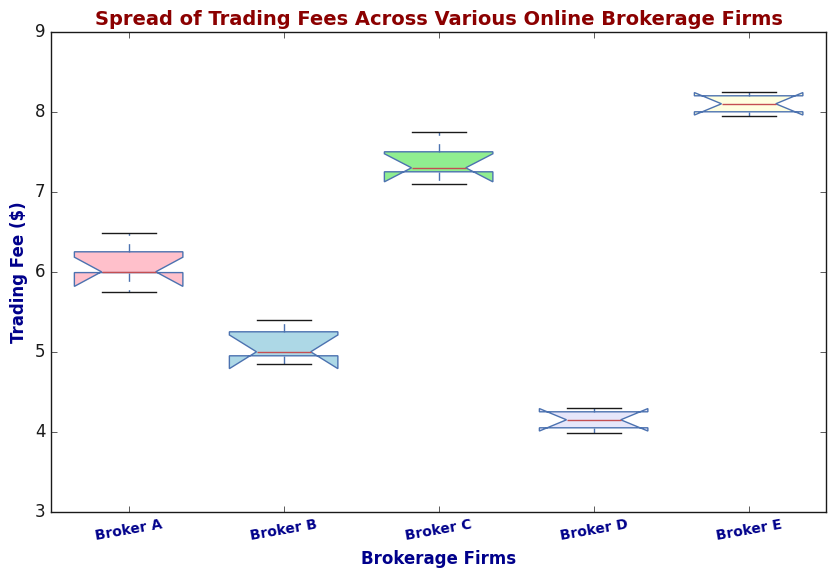What is the median trading fee for Broker D? The box plot shows the median (middle value) as a horizontal line inside the box for Broker D. The line is at the value of approximately 4.15.
Answer: Approximately 4.15 Which brokerage firm has the highest variability in trading fees? Variability is indicated by the spread between the whiskers of the box plot. Broker C has the widest distance between the top and bottom whiskers, indicating the highest variability.
Answer: Broker C What is the interquartile range (IQR) for Broker E? The IQR is the difference between the third quartile (Q3) and the first quartile (Q1). For Broker E, the third quartile appears to be around 8.2 and the first quartile around 8.0. Therefore, IQR = 8.2 - 8.0 = 0.2.
Answer: 0.2 Which brokerage firm has the lowest median trading fee? The median trading fee is shown by the line inside the box for each firm. Broker D has the lowest median trading fee at approximately 4.15.
Answer: Broker D Compare the median trading fees of Broker A and Broker B. Which one is higher? The median trading fee is represented by the horizontal line inside the box. Broker A has a median fee around 6.00, while Broker B has a median fee around 5.00. Thus, Broker A's median fee is higher.
Answer: Broker A Are there any outliers in the trading fees for Broker B? Outliers are typically shown as individual points outside the whiskers. For Broker B, there are no points outside the whiskers, indicating no outliers.
Answer: No What is the range of trading fees for Broker C? The range is the difference between the maximum and minimum values shown by the whiskers. For Broker C, the maximum is around 7.75 and the minimum is around 7.10, so the range is 7.75 - 7.10 = 0.65.
Answer: 0.65 Which broker has the tallest box in the plot? The height of the box represents the interquartile range (IQR). Broker C's box is the tallest, indicating it has the largest IQR.
Answer: Broker C 